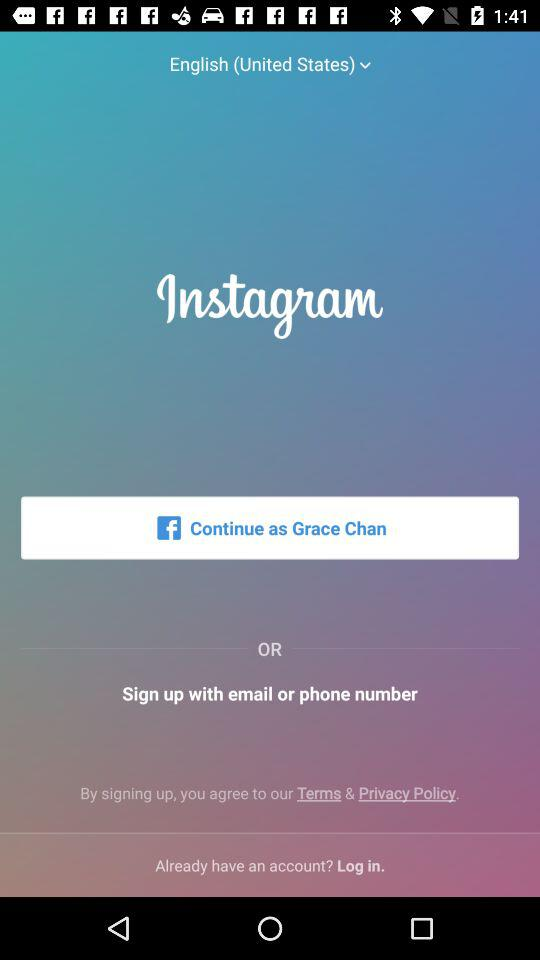What is the app name? The app name is "Instagram". 